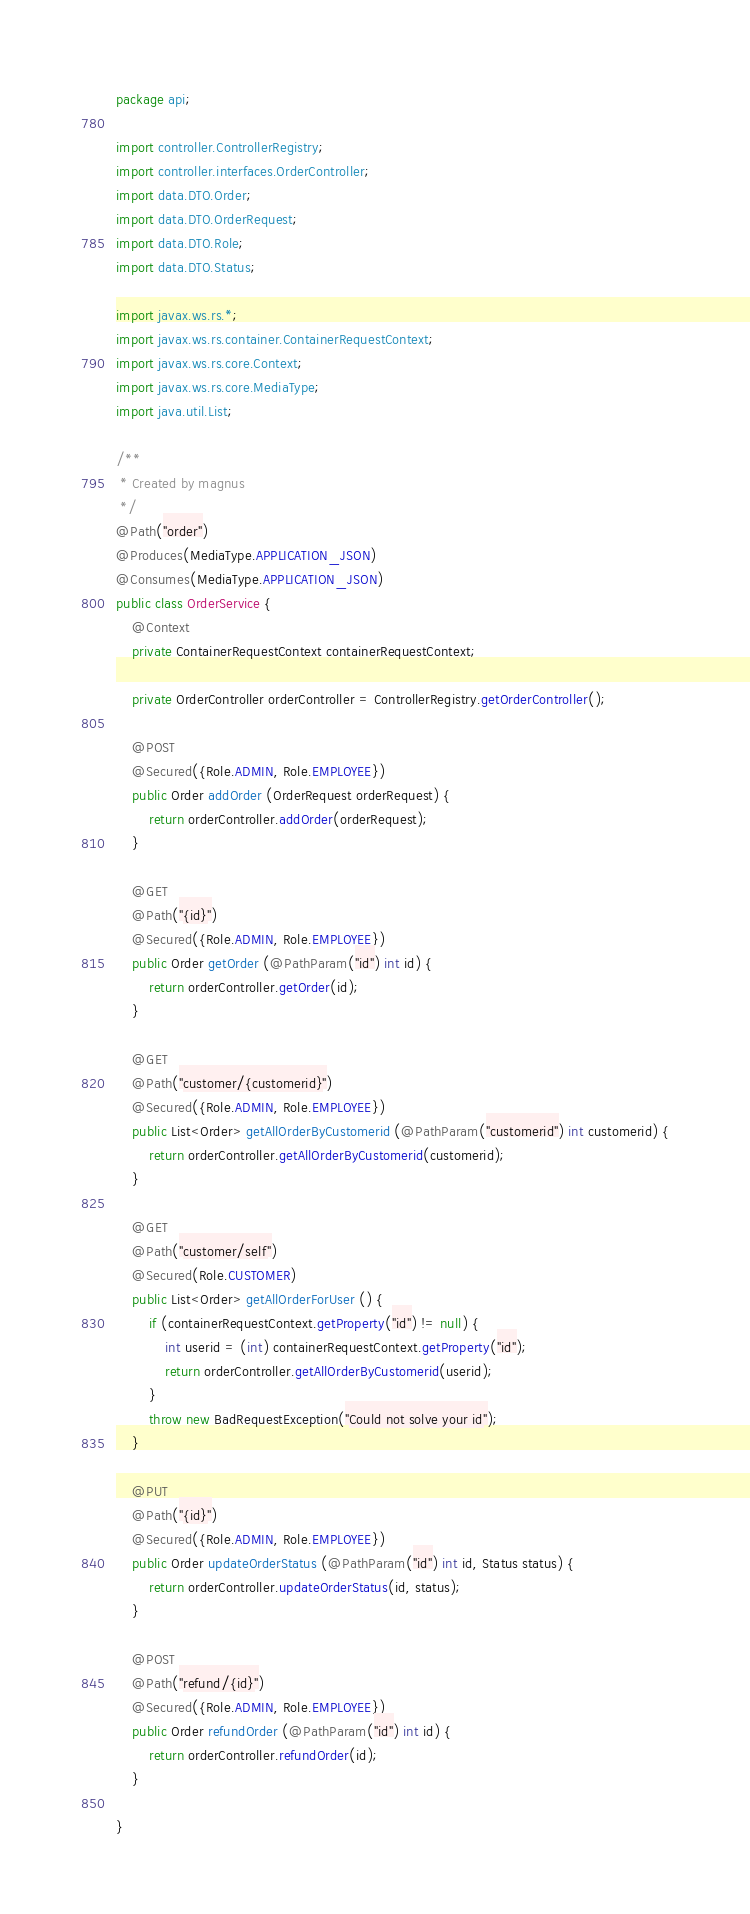Convert code to text. <code><loc_0><loc_0><loc_500><loc_500><_Java_>package api;

import controller.ControllerRegistry;
import controller.interfaces.OrderController;
import data.DTO.Order;
import data.DTO.OrderRequest;
import data.DTO.Role;
import data.DTO.Status;

import javax.ws.rs.*;
import javax.ws.rs.container.ContainerRequestContext;
import javax.ws.rs.core.Context;
import javax.ws.rs.core.MediaType;
import java.util.List;

/**
 * Created by magnus
 */
@Path("order")
@Produces(MediaType.APPLICATION_JSON)
@Consumes(MediaType.APPLICATION_JSON)
public class OrderService {
    @Context
    private ContainerRequestContext containerRequestContext;

    private OrderController orderController = ControllerRegistry.getOrderController();

    @POST
    @Secured({Role.ADMIN, Role.EMPLOYEE})
    public Order addOrder (OrderRequest orderRequest) {
        return orderController.addOrder(orderRequest);
    }

    @GET
    @Path("{id}")
    @Secured({Role.ADMIN, Role.EMPLOYEE})
    public Order getOrder (@PathParam("id") int id) {
        return orderController.getOrder(id);
    }

    @GET
    @Path("customer/{customerid}")
    @Secured({Role.ADMIN, Role.EMPLOYEE})
    public List<Order> getAllOrderByCustomerid (@PathParam("customerid") int customerid) {
        return orderController.getAllOrderByCustomerid(customerid);
    }

    @GET
    @Path("customer/self")
    @Secured(Role.CUSTOMER)
    public List<Order> getAllOrderForUser () {
        if (containerRequestContext.getProperty("id") != null) {
            int userid = (int) containerRequestContext.getProperty("id");
            return orderController.getAllOrderByCustomerid(userid);
        }
        throw new BadRequestException("Could not solve your id");
    }

    @PUT
    @Path("{id}")
    @Secured({Role.ADMIN, Role.EMPLOYEE})
    public Order updateOrderStatus (@PathParam("id") int id, Status status) {
        return orderController.updateOrderStatus(id, status);
    }

    @POST
    @Path("refund/{id}")
    @Secured({Role.ADMIN, Role.EMPLOYEE})
    public Order refundOrder (@PathParam("id") int id) {
        return orderController.refundOrder(id);
    }

}
</code> 